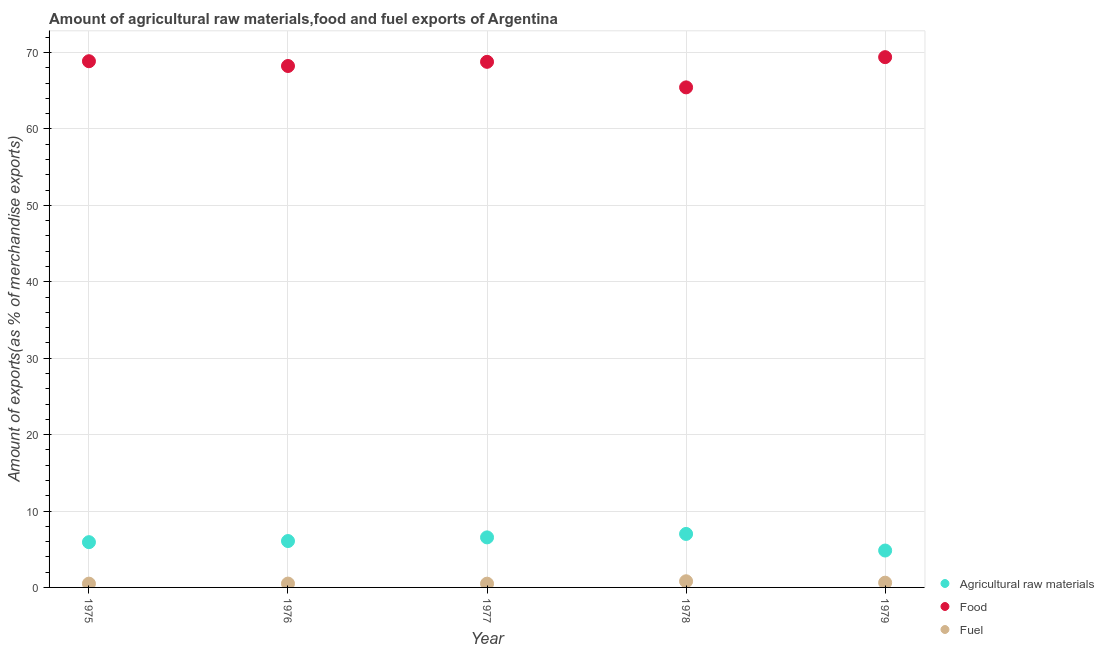What is the percentage of raw materials exports in 1978?
Make the answer very short. 7. Across all years, what is the maximum percentage of raw materials exports?
Provide a succinct answer. 7. Across all years, what is the minimum percentage of fuel exports?
Make the answer very short. 0.49. In which year was the percentage of food exports maximum?
Your answer should be compact. 1979. In which year was the percentage of fuel exports minimum?
Keep it short and to the point. 1977. What is the total percentage of fuel exports in the graph?
Your answer should be very brief. 2.92. What is the difference between the percentage of food exports in 1976 and that in 1977?
Provide a short and direct response. -0.54. What is the difference between the percentage of food exports in 1979 and the percentage of fuel exports in 1976?
Your answer should be compact. 68.9. What is the average percentage of raw materials exports per year?
Give a very brief answer. 6.07. In the year 1979, what is the difference between the percentage of raw materials exports and percentage of food exports?
Your answer should be compact. -64.57. What is the ratio of the percentage of raw materials exports in 1977 to that in 1978?
Offer a terse response. 0.94. What is the difference between the highest and the second highest percentage of fuel exports?
Offer a terse response. 0.19. What is the difference between the highest and the lowest percentage of fuel exports?
Offer a terse response. 0.31. In how many years, is the percentage of raw materials exports greater than the average percentage of raw materials exports taken over all years?
Offer a very short reply. 2. Is it the case that in every year, the sum of the percentage of raw materials exports and percentage of food exports is greater than the percentage of fuel exports?
Offer a terse response. Yes. Is the percentage of raw materials exports strictly greater than the percentage of food exports over the years?
Offer a very short reply. No. Is the percentage of food exports strictly less than the percentage of fuel exports over the years?
Your answer should be compact. No. Are the values on the major ticks of Y-axis written in scientific E-notation?
Keep it short and to the point. No. Does the graph contain any zero values?
Offer a terse response. No. Where does the legend appear in the graph?
Your answer should be compact. Bottom right. How many legend labels are there?
Offer a terse response. 3. How are the legend labels stacked?
Your answer should be compact. Vertical. What is the title of the graph?
Your response must be concise. Amount of agricultural raw materials,food and fuel exports of Argentina. Does "Private sector" appear as one of the legend labels in the graph?
Make the answer very short. No. What is the label or title of the Y-axis?
Provide a short and direct response. Amount of exports(as % of merchandise exports). What is the Amount of exports(as % of merchandise exports) of Agricultural raw materials in 1975?
Your response must be concise. 5.92. What is the Amount of exports(as % of merchandise exports) of Food in 1975?
Your answer should be very brief. 68.87. What is the Amount of exports(as % of merchandise exports) in Fuel in 1975?
Make the answer very short. 0.49. What is the Amount of exports(as % of merchandise exports) in Agricultural raw materials in 1976?
Offer a terse response. 6.07. What is the Amount of exports(as % of merchandise exports) of Food in 1976?
Offer a terse response. 68.24. What is the Amount of exports(as % of merchandise exports) of Fuel in 1976?
Ensure brevity in your answer.  0.5. What is the Amount of exports(as % of merchandise exports) in Agricultural raw materials in 1977?
Make the answer very short. 6.55. What is the Amount of exports(as % of merchandise exports) in Food in 1977?
Your answer should be compact. 68.79. What is the Amount of exports(as % of merchandise exports) of Fuel in 1977?
Offer a very short reply. 0.49. What is the Amount of exports(as % of merchandise exports) of Agricultural raw materials in 1978?
Provide a short and direct response. 7. What is the Amount of exports(as % of merchandise exports) of Food in 1978?
Provide a succinct answer. 65.45. What is the Amount of exports(as % of merchandise exports) in Fuel in 1978?
Provide a short and direct response. 0.81. What is the Amount of exports(as % of merchandise exports) of Agricultural raw materials in 1979?
Give a very brief answer. 4.83. What is the Amount of exports(as % of merchandise exports) of Food in 1979?
Offer a terse response. 69.4. What is the Amount of exports(as % of merchandise exports) in Fuel in 1979?
Your answer should be very brief. 0.62. Across all years, what is the maximum Amount of exports(as % of merchandise exports) in Agricultural raw materials?
Give a very brief answer. 7. Across all years, what is the maximum Amount of exports(as % of merchandise exports) of Food?
Provide a succinct answer. 69.4. Across all years, what is the maximum Amount of exports(as % of merchandise exports) of Fuel?
Make the answer very short. 0.81. Across all years, what is the minimum Amount of exports(as % of merchandise exports) of Agricultural raw materials?
Ensure brevity in your answer.  4.83. Across all years, what is the minimum Amount of exports(as % of merchandise exports) of Food?
Provide a succinct answer. 65.45. Across all years, what is the minimum Amount of exports(as % of merchandise exports) of Fuel?
Make the answer very short. 0.49. What is the total Amount of exports(as % of merchandise exports) of Agricultural raw materials in the graph?
Provide a short and direct response. 30.37. What is the total Amount of exports(as % of merchandise exports) of Food in the graph?
Provide a succinct answer. 340.75. What is the total Amount of exports(as % of merchandise exports) of Fuel in the graph?
Your response must be concise. 2.92. What is the difference between the Amount of exports(as % of merchandise exports) in Agricultural raw materials in 1975 and that in 1976?
Your answer should be very brief. -0.15. What is the difference between the Amount of exports(as % of merchandise exports) of Food in 1975 and that in 1976?
Offer a very short reply. 0.63. What is the difference between the Amount of exports(as % of merchandise exports) of Fuel in 1975 and that in 1976?
Your response must be concise. -0.01. What is the difference between the Amount of exports(as % of merchandise exports) of Agricultural raw materials in 1975 and that in 1977?
Give a very brief answer. -0.63. What is the difference between the Amount of exports(as % of merchandise exports) of Food in 1975 and that in 1977?
Make the answer very short. 0.08. What is the difference between the Amount of exports(as % of merchandise exports) in Fuel in 1975 and that in 1977?
Offer a very short reply. 0. What is the difference between the Amount of exports(as % of merchandise exports) in Agricultural raw materials in 1975 and that in 1978?
Give a very brief answer. -1.08. What is the difference between the Amount of exports(as % of merchandise exports) in Food in 1975 and that in 1978?
Give a very brief answer. 3.42. What is the difference between the Amount of exports(as % of merchandise exports) in Fuel in 1975 and that in 1978?
Provide a succinct answer. -0.31. What is the difference between the Amount of exports(as % of merchandise exports) in Agricultural raw materials in 1975 and that in 1979?
Provide a succinct answer. 1.09. What is the difference between the Amount of exports(as % of merchandise exports) in Food in 1975 and that in 1979?
Offer a terse response. -0.53. What is the difference between the Amount of exports(as % of merchandise exports) of Fuel in 1975 and that in 1979?
Provide a short and direct response. -0.13. What is the difference between the Amount of exports(as % of merchandise exports) of Agricultural raw materials in 1976 and that in 1977?
Offer a terse response. -0.48. What is the difference between the Amount of exports(as % of merchandise exports) in Food in 1976 and that in 1977?
Make the answer very short. -0.54. What is the difference between the Amount of exports(as % of merchandise exports) of Fuel in 1976 and that in 1977?
Give a very brief answer. 0.01. What is the difference between the Amount of exports(as % of merchandise exports) in Agricultural raw materials in 1976 and that in 1978?
Your answer should be compact. -0.93. What is the difference between the Amount of exports(as % of merchandise exports) of Food in 1976 and that in 1978?
Provide a succinct answer. 2.8. What is the difference between the Amount of exports(as % of merchandise exports) of Fuel in 1976 and that in 1978?
Keep it short and to the point. -0.3. What is the difference between the Amount of exports(as % of merchandise exports) in Agricultural raw materials in 1976 and that in 1979?
Provide a succinct answer. 1.24. What is the difference between the Amount of exports(as % of merchandise exports) in Food in 1976 and that in 1979?
Your answer should be compact. -1.16. What is the difference between the Amount of exports(as % of merchandise exports) of Fuel in 1976 and that in 1979?
Keep it short and to the point. -0.12. What is the difference between the Amount of exports(as % of merchandise exports) of Agricultural raw materials in 1977 and that in 1978?
Your answer should be very brief. -0.45. What is the difference between the Amount of exports(as % of merchandise exports) of Food in 1977 and that in 1978?
Your answer should be compact. 3.34. What is the difference between the Amount of exports(as % of merchandise exports) of Fuel in 1977 and that in 1978?
Keep it short and to the point. -0.31. What is the difference between the Amount of exports(as % of merchandise exports) in Agricultural raw materials in 1977 and that in 1979?
Your answer should be very brief. 1.72. What is the difference between the Amount of exports(as % of merchandise exports) of Food in 1977 and that in 1979?
Your answer should be compact. -0.61. What is the difference between the Amount of exports(as % of merchandise exports) in Fuel in 1977 and that in 1979?
Your answer should be very brief. -0.13. What is the difference between the Amount of exports(as % of merchandise exports) of Agricultural raw materials in 1978 and that in 1979?
Ensure brevity in your answer.  2.17. What is the difference between the Amount of exports(as % of merchandise exports) in Food in 1978 and that in 1979?
Give a very brief answer. -3.96. What is the difference between the Amount of exports(as % of merchandise exports) in Fuel in 1978 and that in 1979?
Offer a terse response. 0.19. What is the difference between the Amount of exports(as % of merchandise exports) in Agricultural raw materials in 1975 and the Amount of exports(as % of merchandise exports) in Food in 1976?
Ensure brevity in your answer.  -62.32. What is the difference between the Amount of exports(as % of merchandise exports) of Agricultural raw materials in 1975 and the Amount of exports(as % of merchandise exports) of Fuel in 1976?
Your answer should be compact. 5.42. What is the difference between the Amount of exports(as % of merchandise exports) in Food in 1975 and the Amount of exports(as % of merchandise exports) in Fuel in 1976?
Your answer should be compact. 68.37. What is the difference between the Amount of exports(as % of merchandise exports) in Agricultural raw materials in 1975 and the Amount of exports(as % of merchandise exports) in Food in 1977?
Offer a terse response. -62.86. What is the difference between the Amount of exports(as % of merchandise exports) in Agricultural raw materials in 1975 and the Amount of exports(as % of merchandise exports) in Fuel in 1977?
Offer a terse response. 5.43. What is the difference between the Amount of exports(as % of merchandise exports) of Food in 1975 and the Amount of exports(as % of merchandise exports) of Fuel in 1977?
Offer a terse response. 68.38. What is the difference between the Amount of exports(as % of merchandise exports) in Agricultural raw materials in 1975 and the Amount of exports(as % of merchandise exports) in Food in 1978?
Your response must be concise. -59.52. What is the difference between the Amount of exports(as % of merchandise exports) in Agricultural raw materials in 1975 and the Amount of exports(as % of merchandise exports) in Fuel in 1978?
Your answer should be very brief. 5.12. What is the difference between the Amount of exports(as % of merchandise exports) of Food in 1975 and the Amount of exports(as % of merchandise exports) of Fuel in 1978?
Provide a succinct answer. 68.06. What is the difference between the Amount of exports(as % of merchandise exports) of Agricultural raw materials in 1975 and the Amount of exports(as % of merchandise exports) of Food in 1979?
Ensure brevity in your answer.  -63.48. What is the difference between the Amount of exports(as % of merchandise exports) of Agricultural raw materials in 1975 and the Amount of exports(as % of merchandise exports) of Fuel in 1979?
Your answer should be compact. 5.3. What is the difference between the Amount of exports(as % of merchandise exports) in Food in 1975 and the Amount of exports(as % of merchandise exports) in Fuel in 1979?
Your answer should be very brief. 68.25. What is the difference between the Amount of exports(as % of merchandise exports) of Agricultural raw materials in 1976 and the Amount of exports(as % of merchandise exports) of Food in 1977?
Offer a very short reply. -62.72. What is the difference between the Amount of exports(as % of merchandise exports) in Agricultural raw materials in 1976 and the Amount of exports(as % of merchandise exports) in Fuel in 1977?
Ensure brevity in your answer.  5.58. What is the difference between the Amount of exports(as % of merchandise exports) of Food in 1976 and the Amount of exports(as % of merchandise exports) of Fuel in 1977?
Ensure brevity in your answer.  67.75. What is the difference between the Amount of exports(as % of merchandise exports) in Agricultural raw materials in 1976 and the Amount of exports(as % of merchandise exports) in Food in 1978?
Offer a very short reply. -59.38. What is the difference between the Amount of exports(as % of merchandise exports) of Agricultural raw materials in 1976 and the Amount of exports(as % of merchandise exports) of Fuel in 1978?
Ensure brevity in your answer.  5.26. What is the difference between the Amount of exports(as % of merchandise exports) in Food in 1976 and the Amount of exports(as % of merchandise exports) in Fuel in 1978?
Offer a terse response. 67.44. What is the difference between the Amount of exports(as % of merchandise exports) of Agricultural raw materials in 1976 and the Amount of exports(as % of merchandise exports) of Food in 1979?
Provide a succinct answer. -63.33. What is the difference between the Amount of exports(as % of merchandise exports) in Agricultural raw materials in 1976 and the Amount of exports(as % of merchandise exports) in Fuel in 1979?
Keep it short and to the point. 5.45. What is the difference between the Amount of exports(as % of merchandise exports) of Food in 1976 and the Amount of exports(as % of merchandise exports) of Fuel in 1979?
Keep it short and to the point. 67.62. What is the difference between the Amount of exports(as % of merchandise exports) of Agricultural raw materials in 1977 and the Amount of exports(as % of merchandise exports) of Food in 1978?
Give a very brief answer. -58.9. What is the difference between the Amount of exports(as % of merchandise exports) in Agricultural raw materials in 1977 and the Amount of exports(as % of merchandise exports) in Fuel in 1978?
Offer a terse response. 5.74. What is the difference between the Amount of exports(as % of merchandise exports) of Food in 1977 and the Amount of exports(as % of merchandise exports) of Fuel in 1978?
Make the answer very short. 67.98. What is the difference between the Amount of exports(as % of merchandise exports) of Agricultural raw materials in 1977 and the Amount of exports(as % of merchandise exports) of Food in 1979?
Provide a succinct answer. -62.85. What is the difference between the Amount of exports(as % of merchandise exports) of Agricultural raw materials in 1977 and the Amount of exports(as % of merchandise exports) of Fuel in 1979?
Ensure brevity in your answer.  5.93. What is the difference between the Amount of exports(as % of merchandise exports) of Food in 1977 and the Amount of exports(as % of merchandise exports) of Fuel in 1979?
Your response must be concise. 68.17. What is the difference between the Amount of exports(as % of merchandise exports) in Agricultural raw materials in 1978 and the Amount of exports(as % of merchandise exports) in Food in 1979?
Make the answer very short. -62.4. What is the difference between the Amount of exports(as % of merchandise exports) in Agricultural raw materials in 1978 and the Amount of exports(as % of merchandise exports) in Fuel in 1979?
Keep it short and to the point. 6.38. What is the difference between the Amount of exports(as % of merchandise exports) of Food in 1978 and the Amount of exports(as % of merchandise exports) of Fuel in 1979?
Provide a short and direct response. 64.82. What is the average Amount of exports(as % of merchandise exports) of Agricultural raw materials per year?
Keep it short and to the point. 6.07. What is the average Amount of exports(as % of merchandise exports) in Food per year?
Your response must be concise. 68.15. What is the average Amount of exports(as % of merchandise exports) of Fuel per year?
Ensure brevity in your answer.  0.58. In the year 1975, what is the difference between the Amount of exports(as % of merchandise exports) in Agricultural raw materials and Amount of exports(as % of merchandise exports) in Food?
Keep it short and to the point. -62.95. In the year 1975, what is the difference between the Amount of exports(as % of merchandise exports) of Agricultural raw materials and Amount of exports(as % of merchandise exports) of Fuel?
Offer a terse response. 5.43. In the year 1975, what is the difference between the Amount of exports(as % of merchandise exports) in Food and Amount of exports(as % of merchandise exports) in Fuel?
Keep it short and to the point. 68.37. In the year 1976, what is the difference between the Amount of exports(as % of merchandise exports) in Agricultural raw materials and Amount of exports(as % of merchandise exports) in Food?
Your response must be concise. -62.17. In the year 1976, what is the difference between the Amount of exports(as % of merchandise exports) in Agricultural raw materials and Amount of exports(as % of merchandise exports) in Fuel?
Your answer should be compact. 5.57. In the year 1976, what is the difference between the Amount of exports(as % of merchandise exports) in Food and Amount of exports(as % of merchandise exports) in Fuel?
Give a very brief answer. 67.74. In the year 1977, what is the difference between the Amount of exports(as % of merchandise exports) of Agricultural raw materials and Amount of exports(as % of merchandise exports) of Food?
Make the answer very short. -62.24. In the year 1977, what is the difference between the Amount of exports(as % of merchandise exports) in Agricultural raw materials and Amount of exports(as % of merchandise exports) in Fuel?
Provide a succinct answer. 6.06. In the year 1977, what is the difference between the Amount of exports(as % of merchandise exports) in Food and Amount of exports(as % of merchandise exports) in Fuel?
Offer a very short reply. 68.3. In the year 1978, what is the difference between the Amount of exports(as % of merchandise exports) in Agricultural raw materials and Amount of exports(as % of merchandise exports) in Food?
Ensure brevity in your answer.  -58.45. In the year 1978, what is the difference between the Amount of exports(as % of merchandise exports) of Agricultural raw materials and Amount of exports(as % of merchandise exports) of Fuel?
Provide a succinct answer. 6.19. In the year 1978, what is the difference between the Amount of exports(as % of merchandise exports) of Food and Amount of exports(as % of merchandise exports) of Fuel?
Make the answer very short. 64.64. In the year 1979, what is the difference between the Amount of exports(as % of merchandise exports) of Agricultural raw materials and Amount of exports(as % of merchandise exports) of Food?
Offer a very short reply. -64.57. In the year 1979, what is the difference between the Amount of exports(as % of merchandise exports) in Agricultural raw materials and Amount of exports(as % of merchandise exports) in Fuel?
Offer a very short reply. 4.21. In the year 1979, what is the difference between the Amount of exports(as % of merchandise exports) of Food and Amount of exports(as % of merchandise exports) of Fuel?
Your response must be concise. 68.78. What is the ratio of the Amount of exports(as % of merchandise exports) of Agricultural raw materials in 1975 to that in 1976?
Offer a terse response. 0.98. What is the ratio of the Amount of exports(as % of merchandise exports) of Food in 1975 to that in 1976?
Ensure brevity in your answer.  1.01. What is the ratio of the Amount of exports(as % of merchandise exports) in Fuel in 1975 to that in 1976?
Keep it short and to the point. 0.98. What is the ratio of the Amount of exports(as % of merchandise exports) of Agricultural raw materials in 1975 to that in 1977?
Make the answer very short. 0.9. What is the ratio of the Amount of exports(as % of merchandise exports) of Food in 1975 to that in 1977?
Your answer should be compact. 1. What is the ratio of the Amount of exports(as % of merchandise exports) of Fuel in 1975 to that in 1977?
Your answer should be compact. 1.01. What is the ratio of the Amount of exports(as % of merchandise exports) in Agricultural raw materials in 1975 to that in 1978?
Offer a terse response. 0.85. What is the ratio of the Amount of exports(as % of merchandise exports) of Food in 1975 to that in 1978?
Make the answer very short. 1.05. What is the ratio of the Amount of exports(as % of merchandise exports) in Fuel in 1975 to that in 1978?
Offer a terse response. 0.61. What is the ratio of the Amount of exports(as % of merchandise exports) of Agricultural raw materials in 1975 to that in 1979?
Give a very brief answer. 1.23. What is the ratio of the Amount of exports(as % of merchandise exports) of Fuel in 1975 to that in 1979?
Provide a short and direct response. 0.8. What is the ratio of the Amount of exports(as % of merchandise exports) in Agricultural raw materials in 1976 to that in 1977?
Your response must be concise. 0.93. What is the ratio of the Amount of exports(as % of merchandise exports) of Fuel in 1976 to that in 1977?
Offer a terse response. 1.02. What is the ratio of the Amount of exports(as % of merchandise exports) in Agricultural raw materials in 1976 to that in 1978?
Provide a succinct answer. 0.87. What is the ratio of the Amount of exports(as % of merchandise exports) in Food in 1976 to that in 1978?
Provide a succinct answer. 1.04. What is the ratio of the Amount of exports(as % of merchandise exports) in Fuel in 1976 to that in 1978?
Offer a terse response. 0.62. What is the ratio of the Amount of exports(as % of merchandise exports) in Agricultural raw materials in 1976 to that in 1979?
Your answer should be compact. 1.26. What is the ratio of the Amount of exports(as % of merchandise exports) in Food in 1976 to that in 1979?
Keep it short and to the point. 0.98. What is the ratio of the Amount of exports(as % of merchandise exports) in Fuel in 1976 to that in 1979?
Keep it short and to the point. 0.81. What is the ratio of the Amount of exports(as % of merchandise exports) of Agricultural raw materials in 1977 to that in 1978?
Provide a succinct answer. 0.94. What is the ratio of the Amount of exports(as % of merchandise exports) of Food in 1977 to that in 1978?
Offer a terse response. 1.05. What is the ratio of the Amount of exports(as % of merchandise exports) of Fuel in 1977 to that in 1978?
Make the answer very short. 0.61. What is the ratio of the Amount of exports(as % of merchandise exports) in Agricultural raw materials in 1977 to that in 1979?
Provide a short and direct response. 1.36. What is the ratio of the Amount of exports(as % of merchandise exports) of Food in 1977 to that in 1979?
Keep it short and to the point. 0.99. What is the ratio of the Amount of exports(as % of merchandise exports) of Fuel in 1977 to that in 1979?
Your answer should be very brief. 0.79. What is the ratio of the Amount of exports(as % of merchandise exports) in Agricultural raw materials in 1978 to that in 1979?
Your response must be concise. 1.45. What is the ratio of the Amount of exports(as % of merchandise exports) in Food in 1978 to that in 1979?
Make the answer very short. 0.94. What is the ratio of the Amount of exports(as % of merchandise exports) in Fuel in 1978 to that in 1979?
Your answer should be compact. 1.3. What is the difference between the highest and the second highest Amount of exports(as % of merchandise exports) of Agricultural raw materials?
Make the answer very short. 0.45. What is the difference between the highest and the second highest Amount of exports(as % of merchandise exports) of Food?
Give a very brief answer. 0.53. What is the difference between the highest and the second highest Amount of exports(as % of merchandise exports) in Fuel?
Offer a very short reply. 0.19. What is the difference between the highest and the lowest Amount of exports(as % of merchandise exports) of Agricultural raw materials?
Keep it short and to the point. 2.17. What is the difference between the highest and the lowest Amount of exports(as % of merchandise exports) of Food?
Provide a succinct answer. 3.96. What is the difference between the highest and the lowest Amount of exports(as % of merchandise exports) in Fuel?
Your response must be concise. 0.31. 